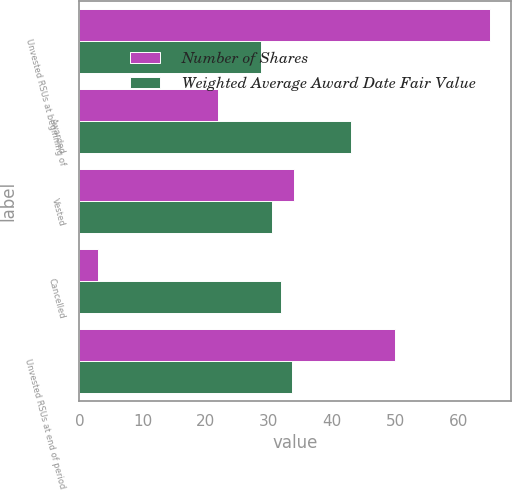<chart> <loc_0><loc_0><loc_500><loc_500><stacked_bar_chart><ecel><fcel>Unvested RSUs at beginning of<fcel>Awarded<fcel>Vested<fcel>Cancelled<fcel>Unvested RSUs at end of period<nl><fcel>Number of Shares<fcel>65<fcel>22<fcel>34<fcel>3<fcel>50<nl><fcel>Weighted Average Award Date Fair Value<fcel>28.7<fcel>42.98<fcel>30.46<fcel>31.96<fcel>33.64<nl></chart> 